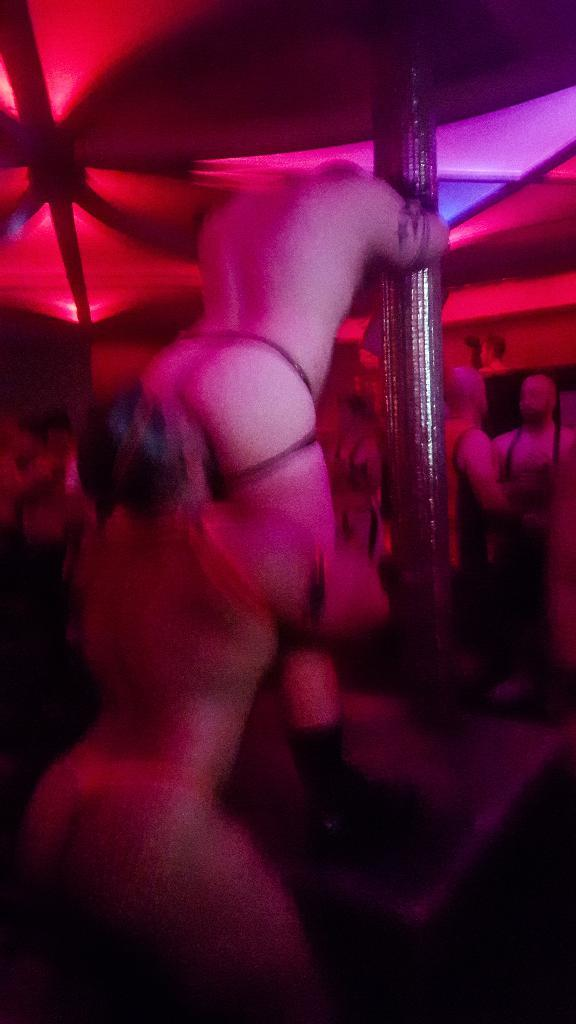How many people are standing near the pole in the image? There are two persons standing near the pole in the image. What can be observed about the background of the image? The background of the image is slightly blurred. Are there any other people visible in the image besides the two standing near the pole? Yes, there are a few people visible in the background. What can be seen in the image that provides illumination? There are lights visible in the image. Can you see the moon in the image? No, the moon is not visible in the image. What type of pen is the person holding in the image? There is no pen present in the image. 